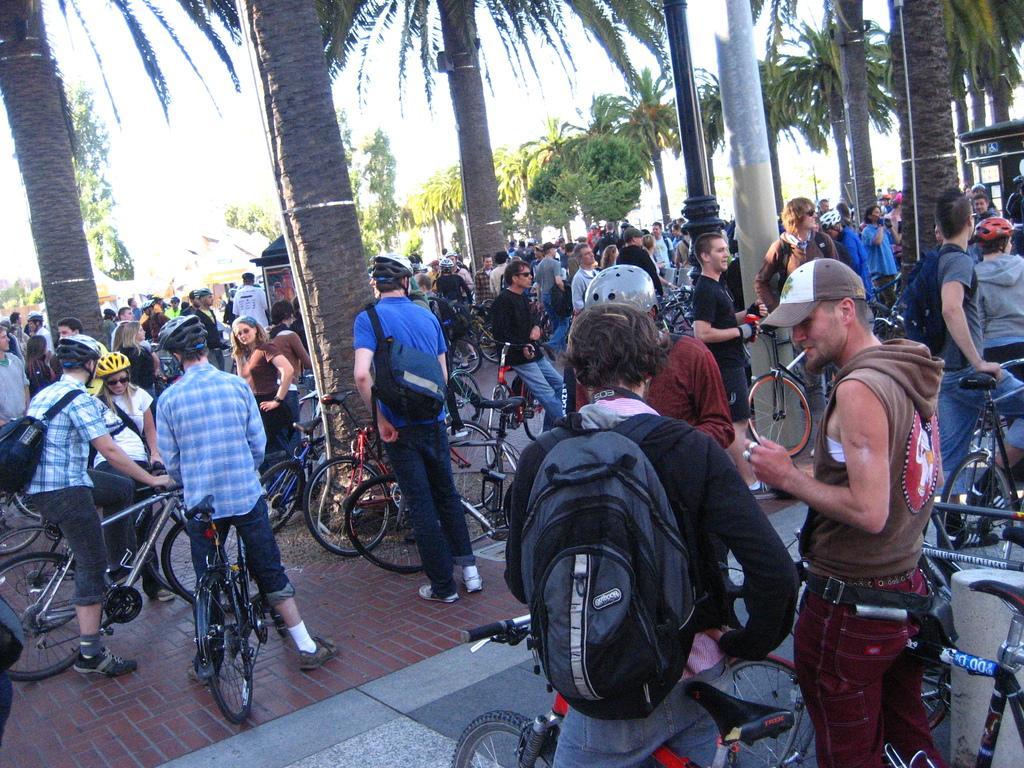What are the people in the image doing? The people in the image are riding bicycles. What can be seen in the background of the image? There are trees visible in the image. What object is present in the image that is not a person or a tree? There is a pole in the image. What type of cake is being served at the birthday celebration in the image? There is no birthday celebration or cake present in the image. Can you describe the bee's behavior in the image? There are no bees present in the image. 